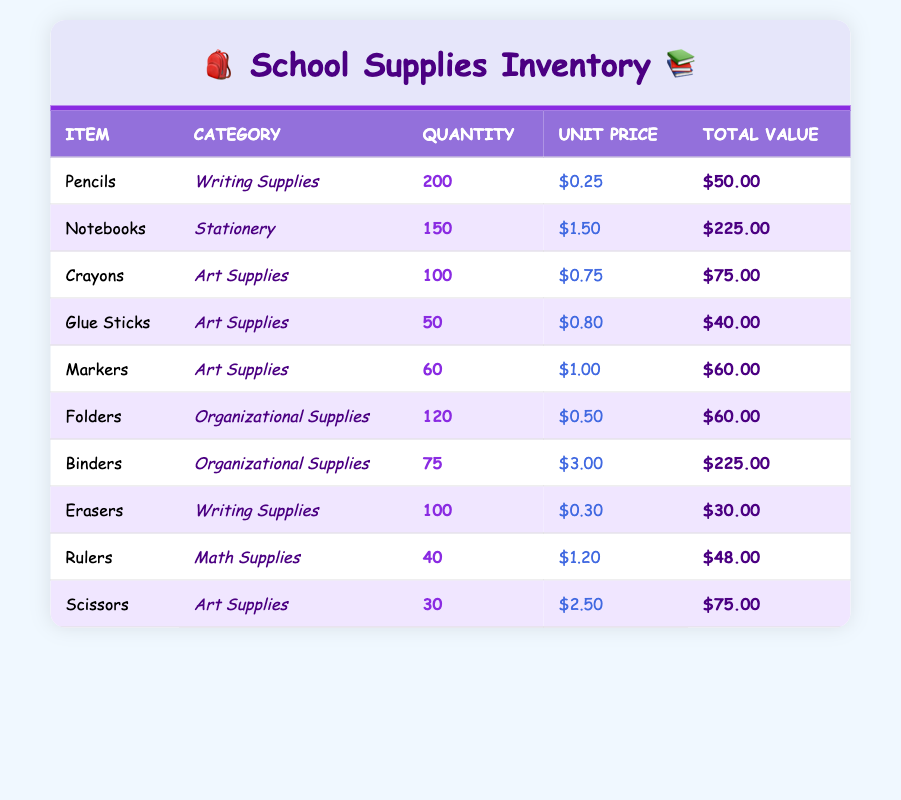What is the total quantity of Writing Supplies? The writing supplies in the inventory are Pencils and Erasers. Their quantities are 200 for Pencils and 100 for Erasers. Adding these together gives us 200 + 100 = 300.
Answer: 300 How many more Notebooks are there compared to Glue Sticks? There are 150 Notebooks and 50 Glue Sticks in the inventory. To find out how many more Notebooks there are than Glue Sticks, we subtract the quantity of Glue Sticks from Notebooks: 150 - 50 = 100.
Answer: 100 What is the total value of all Art Supplies? The Art Supplies in the inventory include Crayons, Glue Sticks, Markers, and Scissors with total values of $75.00, $40.00, $60.00, and $75.00 respectively. Adding these amounts gives us $75 + $40 + $60 + $75 = $250.
Answer: $250 Are there more Folders or Binders in the inventory? There are 120 Folders and 75 Binders. To determine which has more, we can see that 120 is greater than 75, making Folders the larger quantity.
Answer: Yes What is the average unit price of Organizational Supplies? The Organizational Supplies in the inventory consist of Folders at $0.50 and Binders at $3.00. To calculate the average, we add the prices: $0.50 + $3.00 = $3.50. Then, we divide by 2 (the count of items): $3.50 / 2 = $1.75.
Answer: $1.75 How much total value do the supplies in the Math Supplies category contribute? The only item listed in the Math Supplies category is Rulers, which have a total value of $48.00. Since there are no other items in this category, the total value is simply $48.00.
Answer: $48.00 What percentage of the total inventory value is made up by Binders? The total value of all inventory items is $50 + $225 + $75 + $40 + $60 + $60 + $225 + $30 + $48 + $75 = $888. The total value from Binders is $225. To find the percentage, we use the formula (225 / 888) * 100 = approximately 25.34%.
Answer: 25.34% Is it true that there are at least 100 units of any item in the inventory? Yes, there are Pencils (200), Notebooks (150), Crayons (100), and Erasers (100) which all meet this criterion.
Answer: Yes What is the total value of Writing Supplies, and how does it compare to the total value of Art Supplies? The total value of Writing Supplies (Pencils at $50.00 and Erasers at $30.00) is $80.00. The total value of Art Supplies (Crayons at $75.00, Glue Sticks at $40.00, Markers at $60.00, and Scissors at $75.00) amounts to $250. Thus, Writing Supplies total $80.00, which is less than the $250 total for Art Supplies.
Answer: Writing Supplies total $80.00 and are less than Art Supplies total of $250 